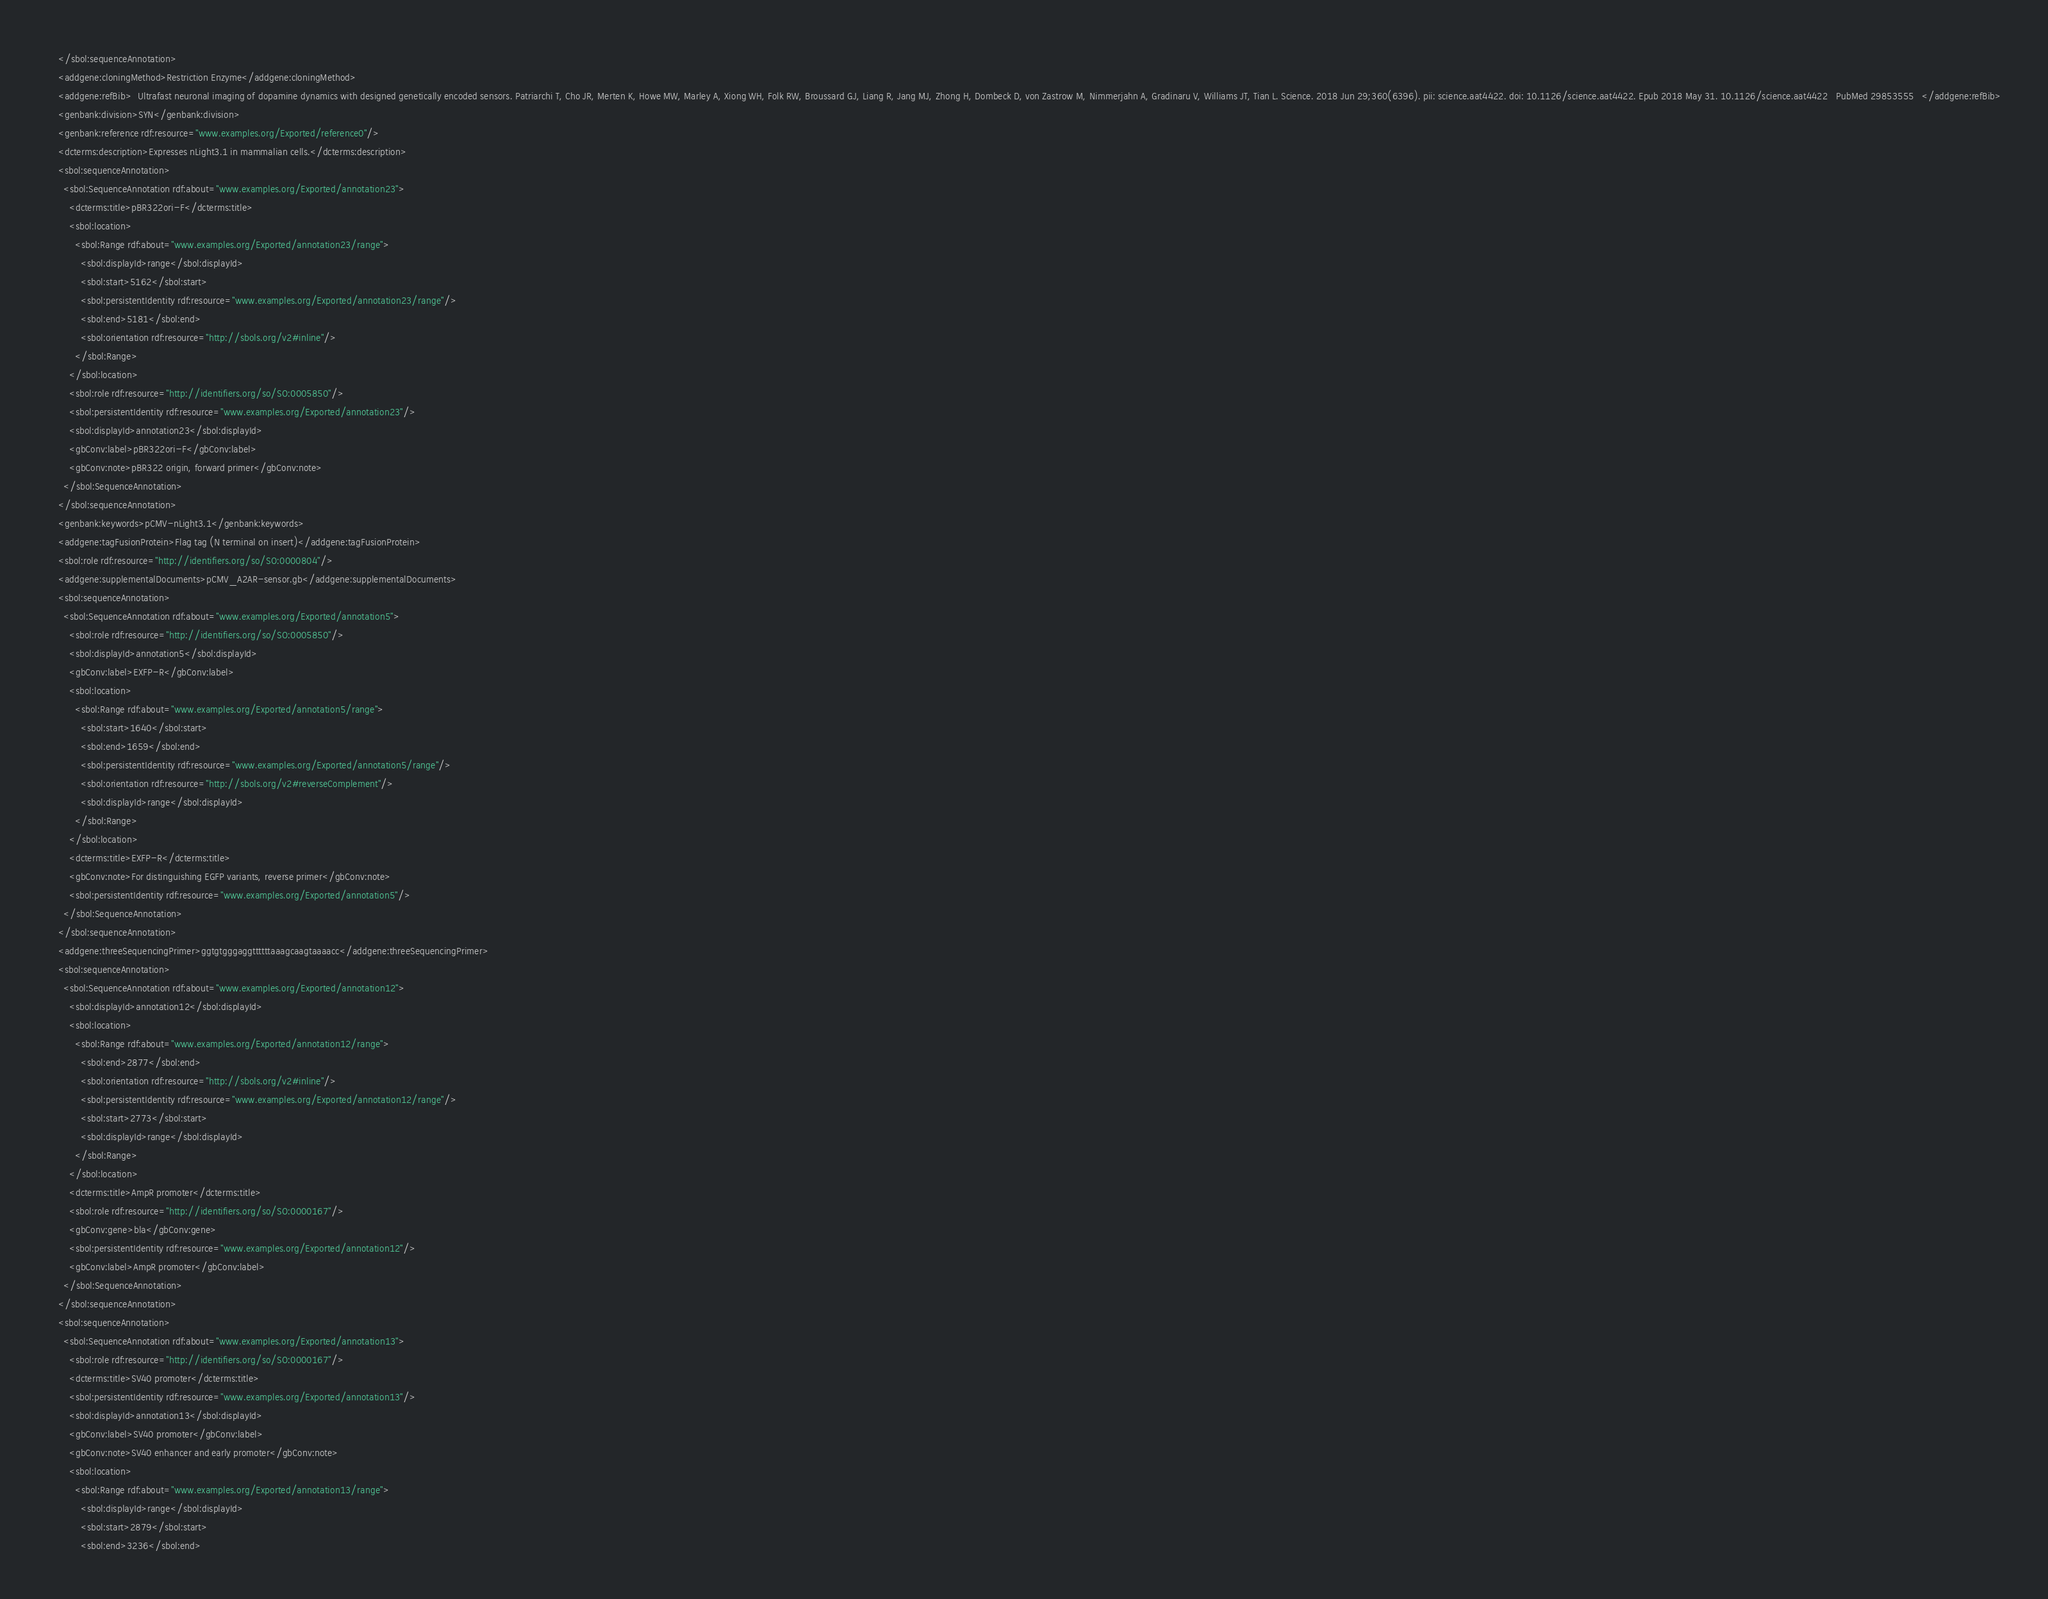Convert code to text. <code><loc_0><loc_0><loc_500><loc_500><_XML_>    </sbol:sequenceAnnotation>
    <addgene:cloningMethod>Restriction Enzyme</addgene:cloningMethod>
    <addgene:refBib>  Ultrafast neuronal imaging of dopamine dynamics with designed genetically encoded sensors. Patriarchi T, Cho JR, Merten K, Howe MW, Marley A, Xiong WH, Folk RW, Broussard GJ, Liang R, Jang MJ, Zhong H, Dombeck D, von Zastrow M, Nimmerjahn A, Gradinaru V, Williams JT, Tian L. Science. 2018 Jun 29;360(6396). pii: science.aat4422. doi: 10.1126/science.aat4422. Epub 2018 May 31. 10.1126/science.aat4422   PubMed 29853555   </addgene:refBib>
    <genbank:division>SYN</genbank:division>
    <genbank:reference rdf:resource="www.examples.org/Exported/reference0"/>
    <dcterms:description>Expresses nLight3.1 in mammalian cells.</dcterms:description>
    <sbol:sequenceAnnotation>
      <sbol:SequenceAnnotation rdf:about="www.examples.org/Exported/annotation23">
        <dcterms:title>pBR322ori-F</dcterms:title>
        <sbol:location>
          <sbol:Range rdf:about="www.examples.org/Exported/annotation23/range">
            <sbol:displayId>range</sbol:displayId>
            <sbol:start>5162</sbol:start>
            <sbol:persistentIdentity rdf:resource="www.examples.org/Exported/annotation23/range"/>
            <sbol:end>5181</sbol:end>
            <sbol:orientation rdf:resource="http://sbols.org/v2#inline"/>
          </sbol:Range>
        </sbol:location>
        <sbol:role rdf:resource="http://identifiers.org/so/SO:0005850"/>
        <sbol:persistentIdentity rdf:resource="www.examples.org/Exported/annotation23"/>
        <sbol:displayId>annotation23</sbol:displayId>
        <gbConv:label>pBR322ori-F</gbConv:label>
        <gbConv:note>pBR322 origin, forward primer</gbConv:note>
      </sbol:SequenceAnnotation>
    </sbol:sequenceAnnotation>
    <genbank:keywords>pCMV-nLight3.1</genbank:keywords>
    <addgene:tagFusionProtein>Flag tag (N terminal on insert)</addgene:tagFusionProtein>
    <sbol:role rdf:resource="http://identifiers.org/so/SO:0000804"/>
    <addgene:supplementalDocuments>pCMV_A2AR-sensor.gb</addgene:supplementalDocuments>
    <sbol:sequenceAnnotation>
      <sbol:SequenceAnnotation rdf:about="www.examples.org/Exported/annotation5">
        <sbol:role rdf:resource="http://identifiers.org/so/SO:0005850"/>
        <sbol:displayId>annotation5</sbol:displayId>
        <gbConv:label>EXFP-R</gbConv:label>
        <sbol:location>
          <sbol:Range rdf:about="www.examples.org/Exported/annotation5/range">
            <sbol:start>1640</sbol:start>
            <sbol:end>1659</sbol:end>
            <sbol:persistentIdentity rdf:resource="www.examples.org/Exported/annotation5/range"/>
            <sbol:orientation rdf:resource="http://sbols.org/v2#reverseComplement"/>
            <sbol:displayId>range</sbol:displayId>
          </sbol:Range>
        </sbol:location>
        <dcterms:title>EXFP-R</dcterms:title>
        <gbConv:note>For distinguishing EGFP variants, reverse primer</gbConv:note>
        <sbol:persistentIdentity rdf:resource="www.examples.org/Exported/annotation5"/>
      </sbol:SequenceAnnotation>
    </sbol:sequenceAnnotation>
    <addgene:threeSequencingPrimer>ggtgtgggaggttttttaaagcaagtaaaacc</addgene:threeSequencingPrimer>
    <sbol:sequenceAnnotation>
      <sbol:SequenceAnnotation rdf:about="www.examples.org/Exported/annotation12">
        <sbol:displayId>annotation12</sbol:displayId>
        <sbol:location>
          <sbol:Range rdf:about="www.examples.org/Exported/annotation12/range">
            <sbol:end>2877</sbol:end>
            <sbol:orientation rdf:resource="http://sbols.org/v2#inline"/>
            <sbol:persistentIdentity rdf:resource="www.examples.org/Exported/annotation12/range"/>
            <sbol:start>2773</sbol:start>
            <sbol:displayId>range</sbol:displayId>
          </sbol:Range>
        </sbol:location>
        <dcterms:title>AmpR promoter</dcterms:title>
        <sbol:role rdf:resource="http://identifiers.org/so/SO:0000167"/>
        <gbConv:gene>bla</gbConv:gene>
        <sbol:persistentIdentity rdf:resource="www.examples.org/Exported/annotation12"/>
        <gbConv:label>AmpR promoter</gbConv:label>
      </sbol:SequenceAnnotation>
    </sbol:sequenceAnnotation>
    <sbol:sequenceAnnotation>
      <sbol:SequenceAnnotation rdf:about="www.examples.org/Exported/annotation13">
        <sbol:role rdf:resource="http://identifiers.org/so/SO:0000167"/>
        <dcterms:title>SV40 promoter</dcterms:title>
        <sbol:persistentIdentity rdf:resource="www.examples.org/Exported/annotation13"/>
        <sbol:displayId>annotation13</sbol:displayId>
        <gbConv:label>SV40 promoter</gbConv:label>
        <gbConv:note>SV40 enhancer and early promoter</gbConv:note>
        <sbol:location>
          <sbol:Range rdf:about="www.examples.org/Exported/annotation13/range">
            <sbol:displayId>range</sbol:displayId>
            <sbol:start>2879</sbol:start>
            <sbol:end>3236</sbol:end></code> 